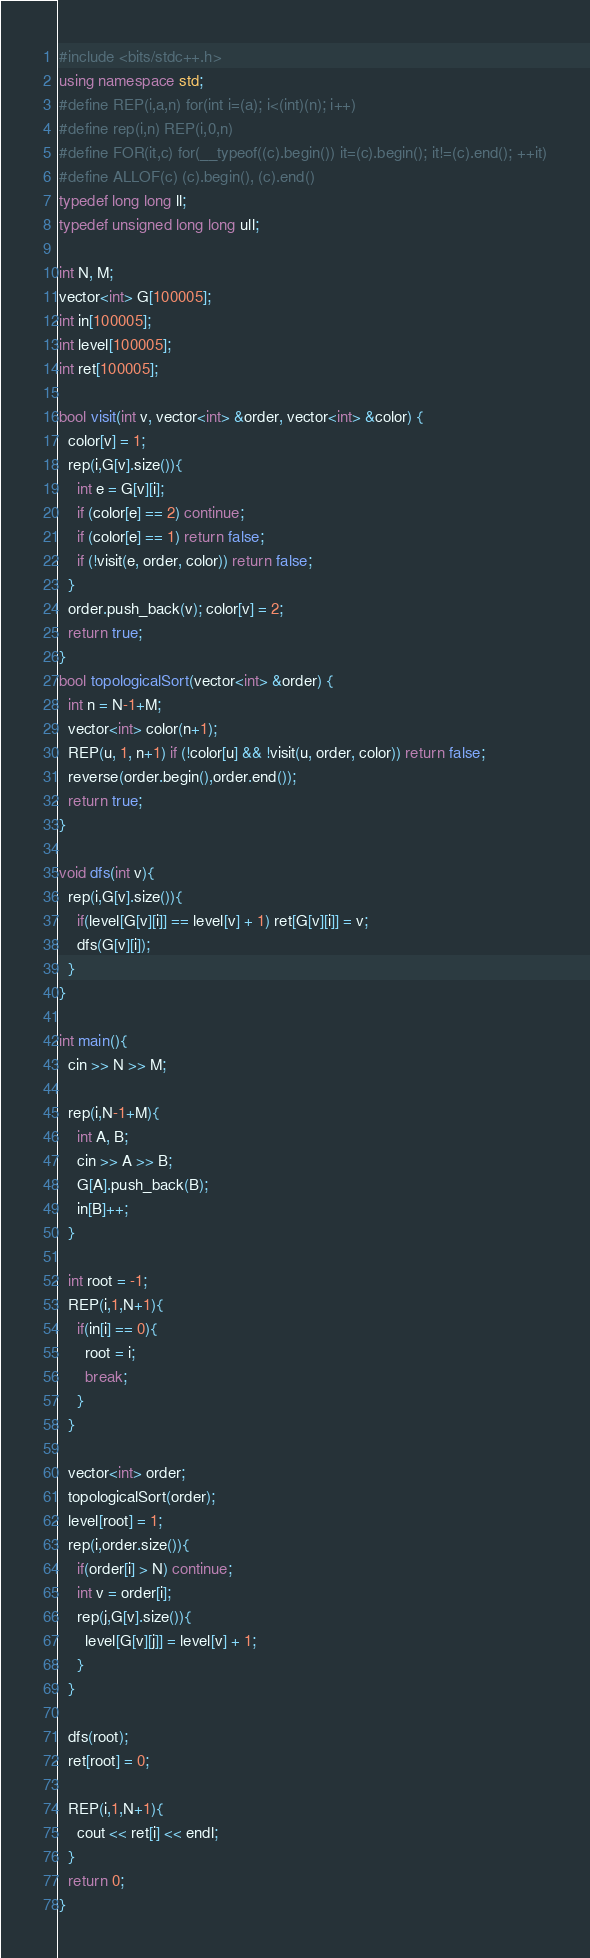<code> <loc_0><loc_0><loc_500><loc_500><_C++_>#include <bits/stdc++.h>
using namespace std;
#define REP(i,a,n) for(int i=(a); i<(int)(n); i++)
#define rep(i,n) REP(i,0,n)
#define FOR(it,c) for(__typeof((c).begin()) it=(c).begin(); it!=(c).end(); ++it)
#define ALLOF(c) (c).begin(), (c).end()
typedef long long ll;
typedef unsigned long long ull;

int N, M;
vector<int> G[100005];
int in[100005];
int level[100005];
int ret[100005];

bool visit(int v, vector<int> &order, vector<int> &color) {
  color[v] = 1;
  rep(i,G[v].size()){
    int e = G[v][i];
    if (color[e] == 2) continue;
    if (color[e] == 1) return false;
    if (!visit(e, order, color)) return false;
  }
  order.push_back(v); color[v] = 2;
  return true;
}
bool topologicalSort(vector<int> &order) {
  int n = N-1+M;
  vector<int> color(n+1);
  REP(u, 1, n+1) if (!color[u] && !visit(u, order, color)) return false;
  reverse(order.begin(),order.end());
  return true;
}

void dfs(int v){
  rep(i,G[v].size()){
    if(level[G[v][i]] == level[v] + 1) ret[G[v][i]] = v;
    dfs(G[v][i]);
  }  
}

int main(){
  cin >> N >> M;

  rep(i,N-1+M){
    int A, B;
    cin >> A >> B;
    G[A].push_back(B);
    in[B]++;
  }

  int root = -1;
  REP(i,1,N+1){
    if(in[i] == 0){
      root = i;
      break;
    }
  }

  vector<int> order;
  topologicalSort(order);
  level[root] = 1;
  rep(i,order.size()){
    if(order[i] > N) continue;
    int v = order[i];
    rep(j,G[v].size()){
      level[G[v][j]] = level[v] + 1;
    }
  }
  
  dfs(root);
  ret[root] = 0;
  
  REP(i,1,N+1){
    cout << ret[i] << endl;
  }
  return 0;
}
</code> 